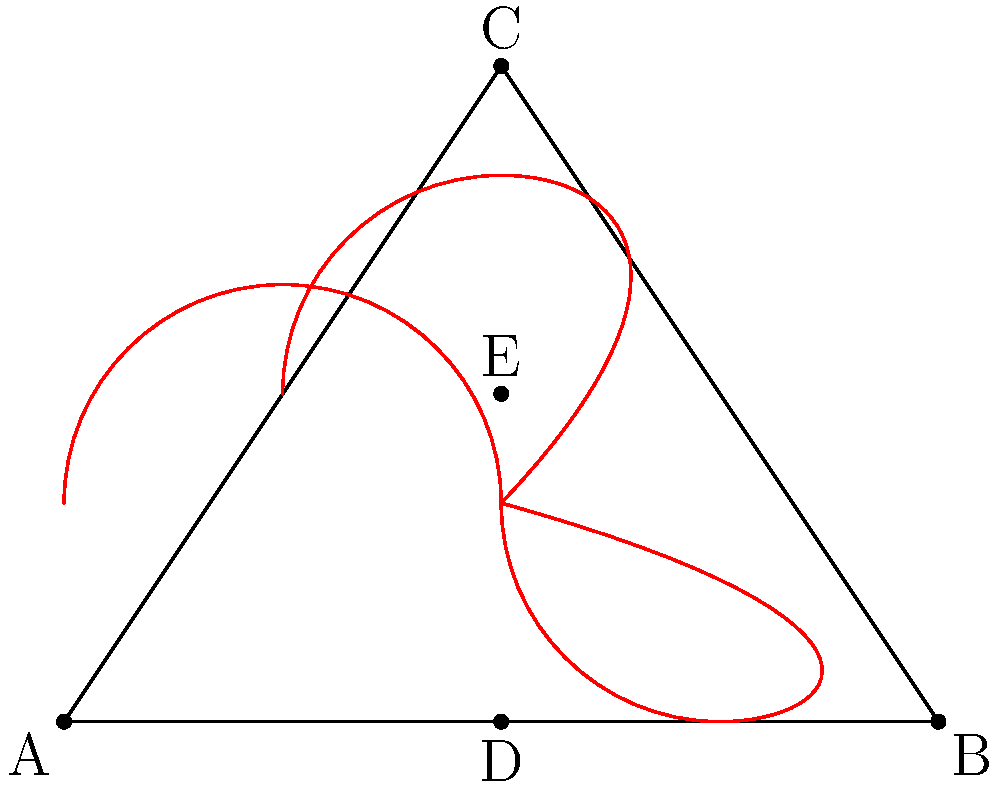For a heart-shaped neckline on a wedding dress, the designer uses two semicircles connected by a central point. If the width of the heart (AB) is 4 inches and the height from the base to the central point (DE) is 1.5 inches, what is the total length of the curved edge of the heart-shaped neckline? Let's approach this step-by-step:

1) The heart shape is composed of two semicircles. Each semicircle has a radius of half the distance between its center and the center of the other semicircle.

2) The width of the heart (AB) is 4 inches. The centers of the semicircles are 2 inches apart (half of AB).

3) The radius of each semicircle is half of this distance: $r = 1$ inch.

4) The circumference of a full circle with radius 1 inch is:
   $C = 2\pi r = 2\pi(1) = 2\pi$ inches

5) We only need half of each circle (semicircles), so the length of each semicircle is:
   $L_{semicircle} = \frac{1}{2} \cdot 2\pi = \pi$ inches

6) The total heart shape consists of two of these semicircles, so the total length is:
   $L_{total} = 2\pi$ inches

Therefore, the total length of the curved edge of the heart-shaped neckline is $2\pi$ inches.
Answer: $2\pi$ inches 